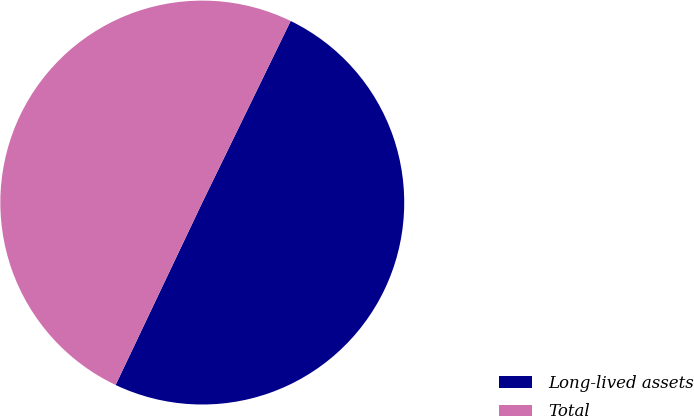Convert chart to OTSL. <chart><loc_0><loc_0><loc_500><loc_500><pie_chart><fcel>Long-lived assets<fcel>Total<nl><fcel>49.85%<fcel>50.15%<nl></chart> 